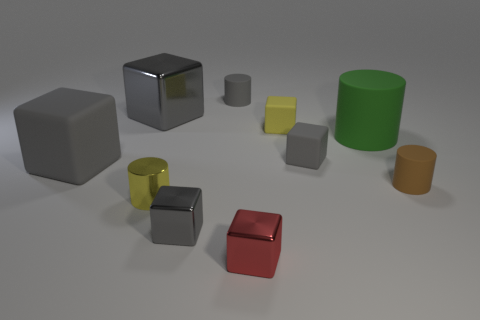How big is the thing that is behind the gray shiny object behind the metallic cylinder?
Offer a terse response. Small. There is a gray shiny thing that is behind the small gray metal cube; is it the same shape as the tiny yellow object that is on the left side of the red metal block?
Ensure brevity in your answer.  No. The yellow object in front of the large gray block left of the large shiny cube is what shape?
Your answer should be compact. Cylinder. How big is the gray thing that is both behind the green rubber thing and left of the small gray shiny cube?
Your response must be concise. Large. There is a big gray rubber thing; is its shape the same as the gray object that is in front of the metal cylinder?
Provide a succinct answer. Yes. What is the size of the yellow rubber object that is the same shape as the red object?
Ensure brevity in your answer.  Small. Does the small metallic cylinder have the same color as the big rubber object left of the small gray rubber cylinder?
Your response must be concise. No. What number of other objects are the same size as the yellow rubber object?
Make the answer very short. 6. What shape is the large matte thing on the right side of the shiny cube that is to the left of the tiny cylinder on the left side of the small gray shiny block?
Give a very brief answer. Cylinder. Does the yellow rubber block have the same size as the shiny cube behind the yellow metal cylinder?
Offer a terse response. No. 